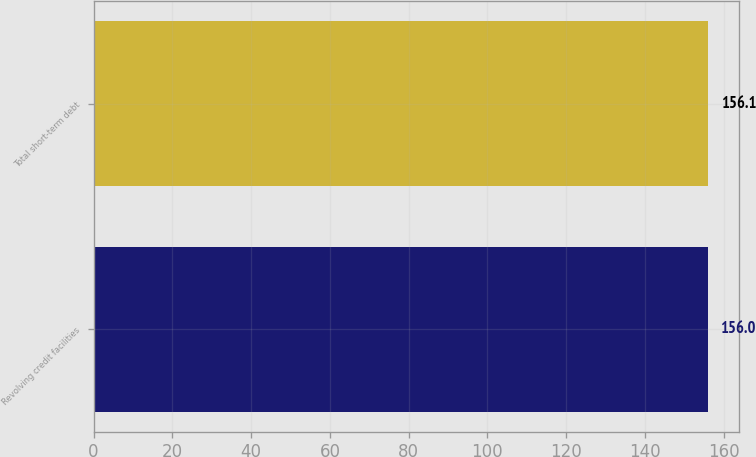Convert chart to OTSL. <chart><loc_0><loc_0><loc_500><loc_500><bar_chart><fcel>Revolving credit facilities<fcel>Total short-term debt<nl><fcel>156<fcel>156.1<nl></chart> 